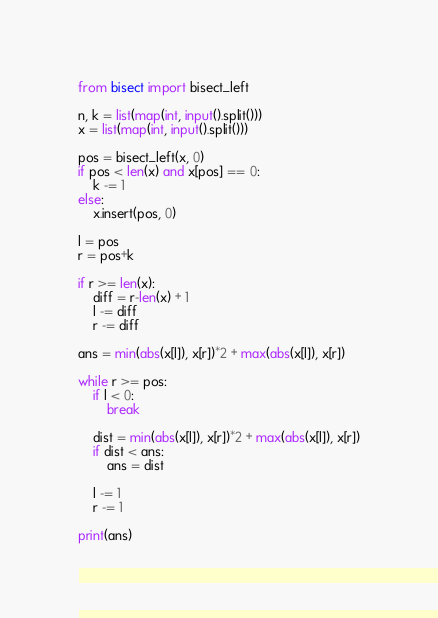Convert code to text. <code><loc_0><loc_0><loc_500><loc_500><_Python_>from bisect import bisect_left

n, k = list(map(int, input().split()))
x = list(map(int, input().split()))

pos = bisect_left(x, 0)
if pos < len(x) and x[pos] == 0:
    k -= 1
else:
    x.insert(pos, 0)

l = pos
r = pos+k

if r >= len(x):
    diff = r-len(x) + 1
    l -= diff
    r -= diff

ans = min(abs(x[l]), x[r])*2 + max(abs(x[l]), x[r])

while r >= pos:
    if l < 0:
        break

    dist = min(abs(x[l]), x[r])*2 + max(abs(x[l]), x[r])
    if dist < ans:
        ans = dist

    l -= 1
    r -= 1

print(ans)</code> 